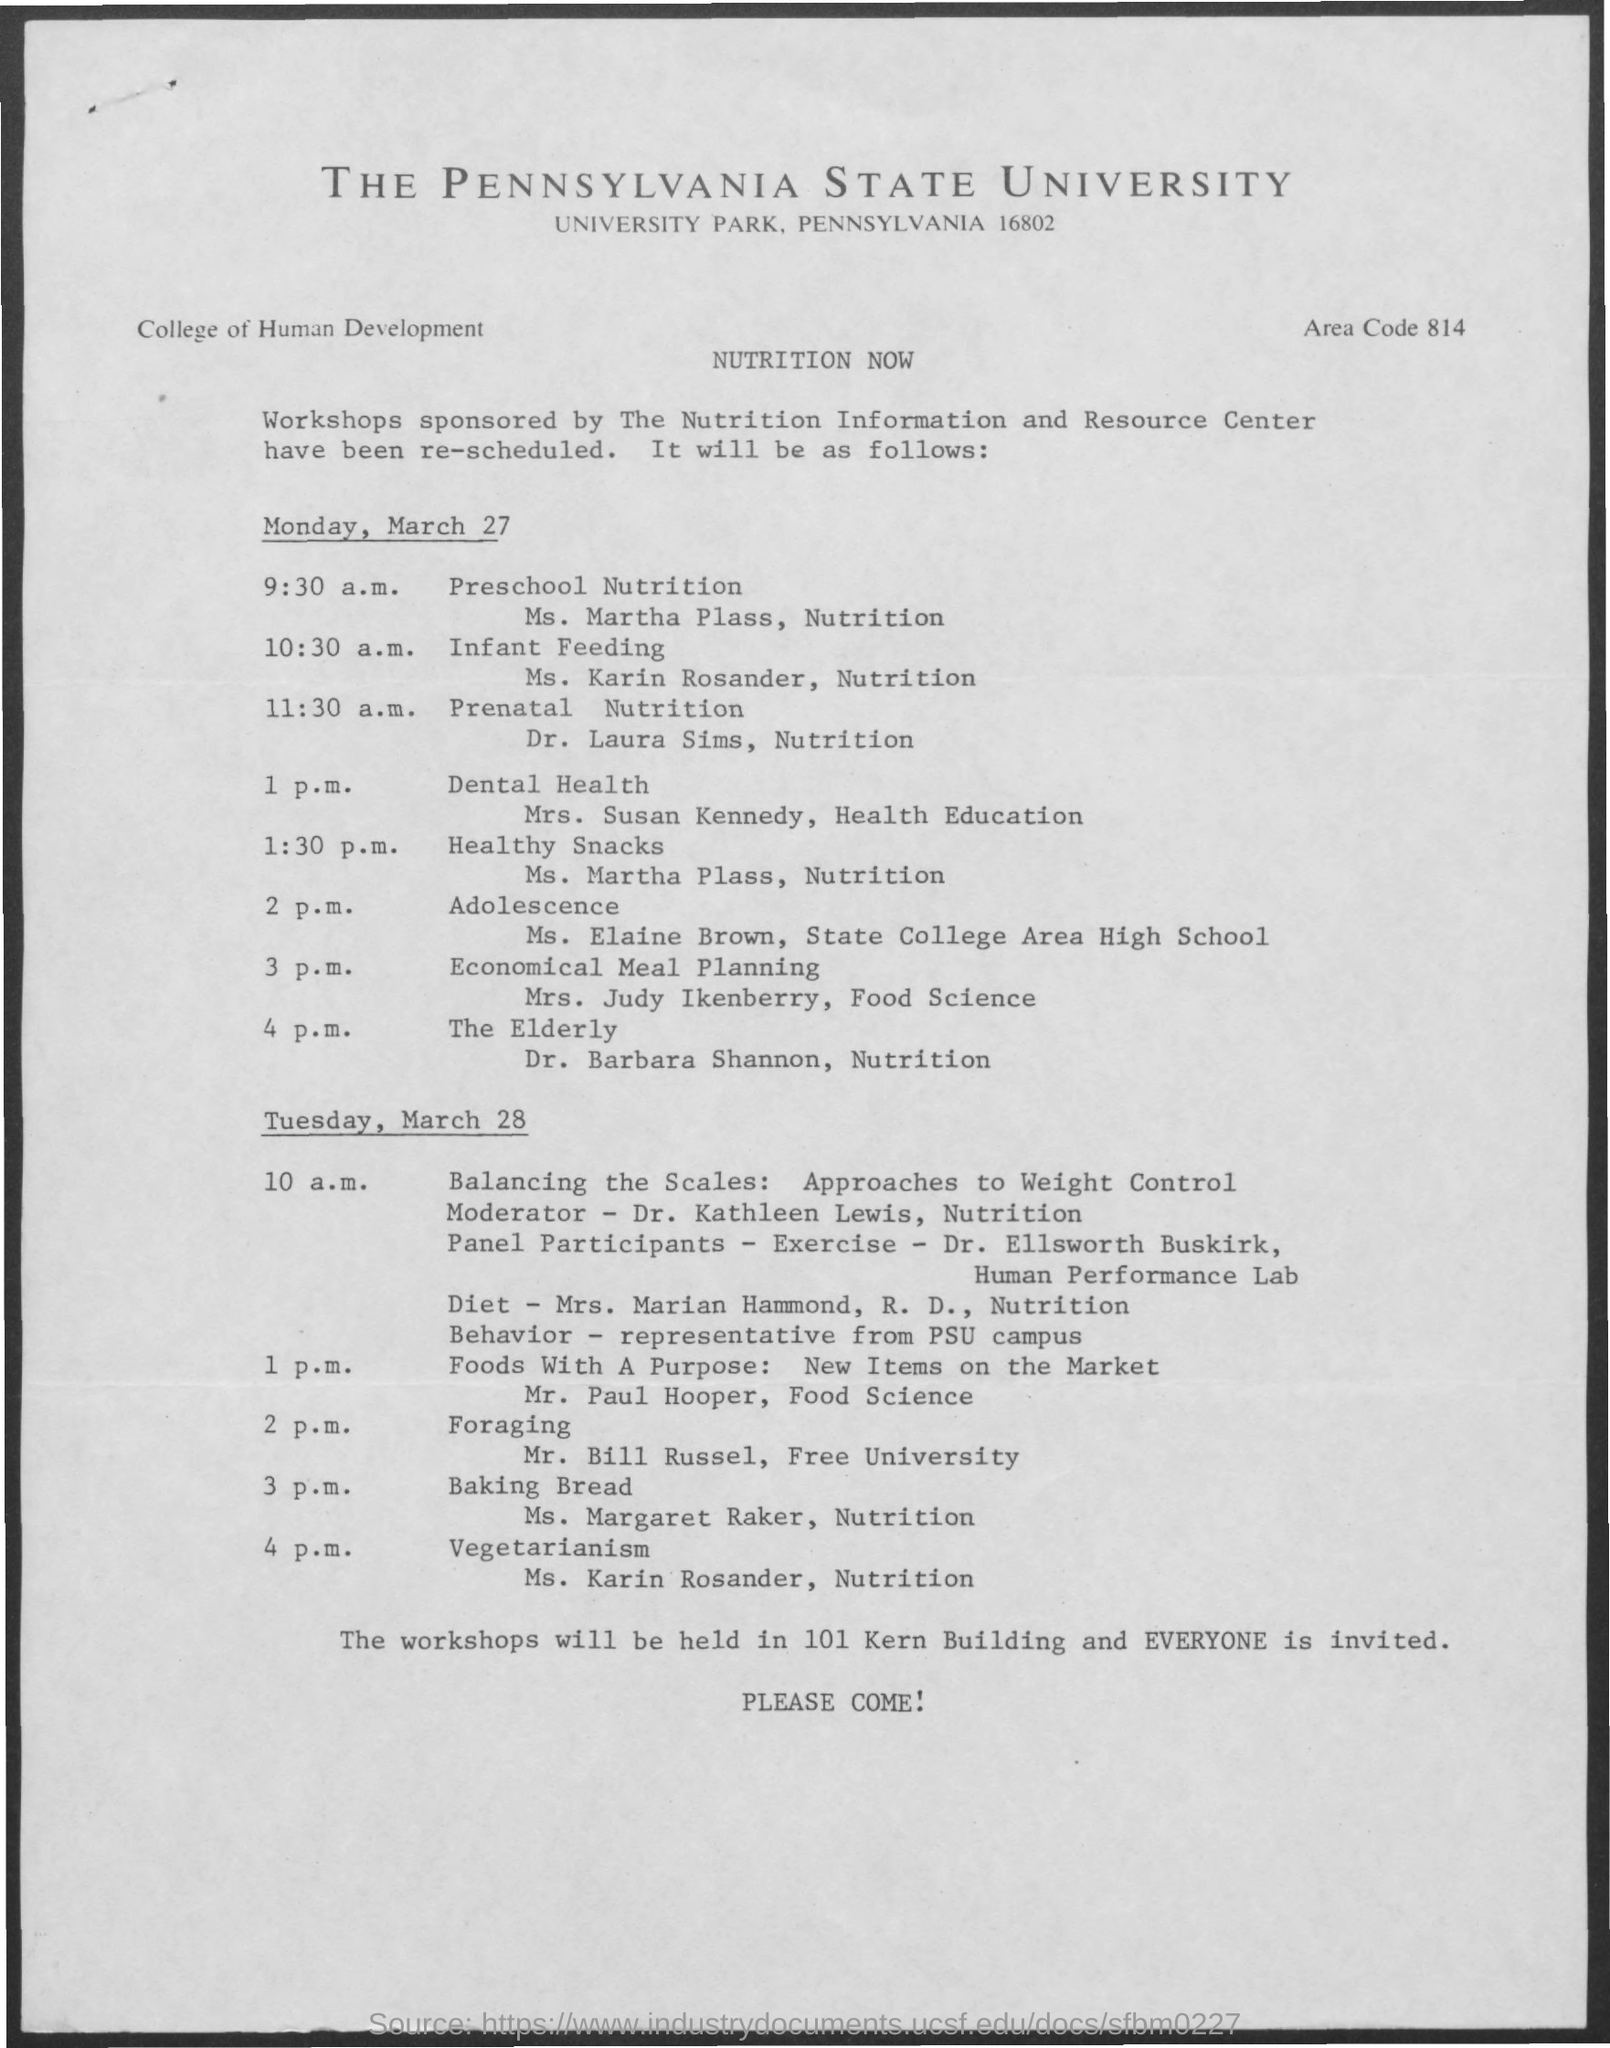What is the area code mentioned in the given page ?
Give a very brief answer. 814. What is the scheduled time for preschool nutrition ?
Your answer should be very brief. 9:30 am. What is the schedule at the time of 3 pm on monday , march 27 ?
Give a very brief answer. Economical meal planning. What is the schedule at the time of 1:30 pm on monday , march 27 ?
Offer a terse response. Healthy snacks. What is the schedule at the time of 3 pm on tuesday , march 28 ?
Provide a succinct answer. Baking Bread. What is the schedule at the time of 2 pm on tuesday , march 28 ?
Make the answer very short. Foraging. Where will be the workshops conducted ?
Provide a succinct answer. 101 Kern Building. 